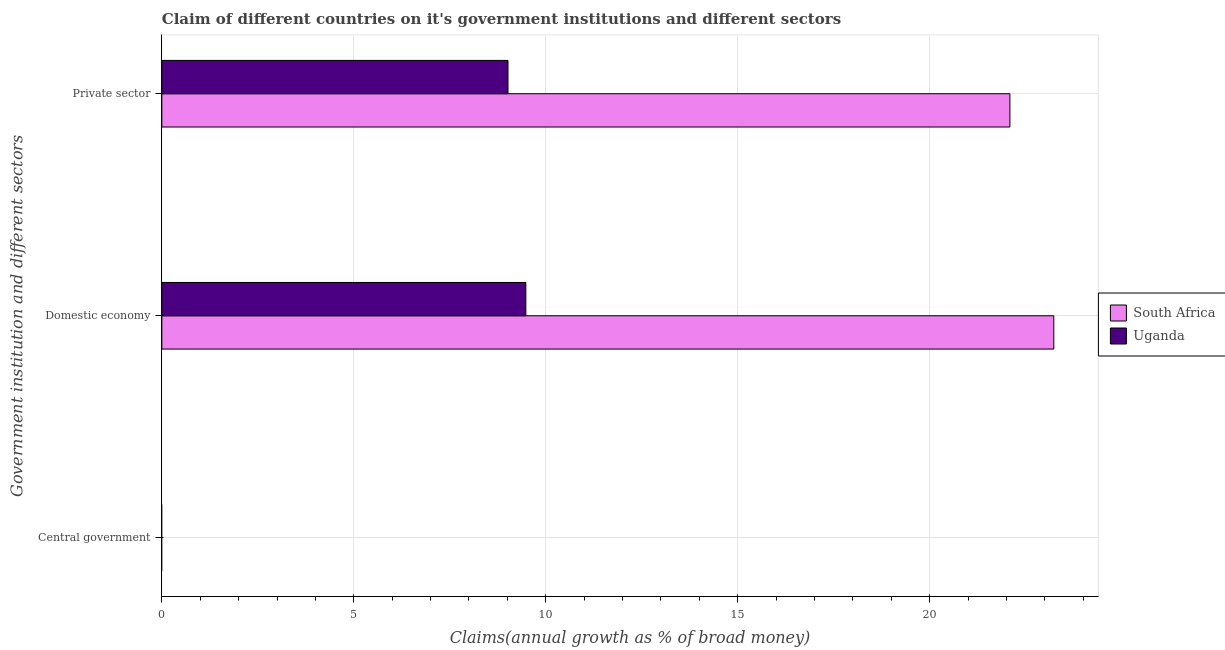How many different coloured bars are there?
Your answer should be very brief. 2. Are the number of bars per tick equal to the number of legend labels?
Give a very brief answer. No. Are the number of bars on each tick of the Y-axis equal?
Your answer should be compact. No. How many bars are there on the 1st tick from the top?
Keep it short and to the point. 2. How many bars are there on the 1st tick from the bottom?
Keep it short and to the point. 0. What is the label of the 2nd group of bars from the top?
Your response must be concise. Domestic economy. What is the percentage of claim on the domestic economy in South Africa?
Give a very brief answer. 23.23. Across all countries, what is the maximum percentage of claim on the private sector?
Provide a succinct answer. 22.09. Across all countries, what is the minimum percentage of claim on the central government?
Offer a very short reply. 0. In which country was the percentage of claim on the private sector maximum?
Your answer should be compact. South Africa. What is the total percentage of claim on the central government in the graph?
Provide a short and direct response. 0. What is the difference between the percentage of claim on the private sector in Uganda and that in South Africa?
Keep it short and to the point. -13.07. What is the difference between the percentage of claim on the central government in Uganda and the percentage of claim on the private sector in South Africa?
Give a very brief answer. -22.09. What is the average percentage of claim on the central government per country?
Ensure brevity in your answer.  0. What is the difference between the percentage of claim on the private sector and percentage of claim on the domestic economy in Uganda?
Your answer should be compact. -0.46. In how many countries, is the percentage of claim on the central government greater than 13 %?
Give a very brief answer. 0. What is the ratio of the percentage of claim on the private sector in Uganda to that in South Africa?
Provide a short and direct response. 0.41. Is the percentage of claim on the domestic economy in South Africa less than that in Uganda?
Your answer should be very brief. No. Is the difference between the percentage of claim on the domestic economy in South Africa and Uganda greater than the difference between the percentage of claim on the private sector in South Africa and Uganda?
Give a very brief answer. Yes. What is the difference between the highest and the second highest percentage of claim on the domestic economy?
Offer a terse response. 13.75. What is the difference between the highest and the lowest percentage of claim on the private sector?
Your response must be concise. 13.07. In how many countries, is the percentage of claim on the central government greater than the average percentage of claim on the central government taken over all countries?
Your answer should be very brief. 0. Is it the case that in every country, the sum of the percentage of claim on the central government and percentage of claim on the domestic economy is greater than the percentage of claim on the private sector?
Ensure brevity in your answer.  Yes. How many bars are there?
Offer a very short reply. 4. What is the difference between two consecutive major ticks on the X-axis?
Keep it short and to the point. 5. Where does the legend appear in the graph?
Provide a succinct answer. Center right. How many legend labels are there?
Provide a succinct answer. 2. What is the title of the graph?
Your response must be concise. Claim of different countries on it's government institutions and different sectors. Does "Japan" appear as one of the legend labels in the graph?
Your answer should be compact. No. What is the label or title of the X-axis?
Offer a terse response. Claims(annual growth as % of broad money). What is the label or title of the Y-axis?
Provide a short and direct response. Government institution and different sectors. What is the Claims(annual growth as % of broad money) in South Africa in Domestic economy?
Give a very brief answer. 23.23. What is the Claims(annual growth as % of broad money) in Uganda in Domestic economy?
Your response must be concise. 9.48. What is the Claims(annual growth as % of broad money) in South Africa in Private sector?
Keep it short and to the point. 22.09. What is the Claims(annual growth as % of broad money) in Uganda in Private sector?
Offer a terse response. 9.02. Across all Government institution and different sectors, what is the maximum Claims(annual growth as % of broad money) in South Africa?
Offer a terse response. 23.23. Across all Government institution and different sectors, what is the maximum Claims(annual growth as % of broad money) in Uganda?
Make the answer very short. 9.48. What is the total Claims(annual growth as % of broad money) in South Africa in the graph?
Your response must be concise. 45.32. What is the total Claims(annual growth as % of broad money) in Uganda in the graph?
Offer a very short reply. 18.5. What is the difference between the Claims(annual growth as % of broad money) in South Africa in Domestic economy and that in Private sector?
Keep it short and to the point. 1.14. What is the difference between the Claims(annual growth as % of broad money) of Uganda in Domestic economy and that in Private sector?
Offer a terse response. 0.46. What is the difference between the Claims(annual growth as % of broad money) in South Africa in Domestic economy and the Claims(annual growth as % of broad money) in Uganda in Private sector?
Your answer should be very brief. 14.22. What is the average Claims(annual growth as % of broad money) in South Africa per Government institution and different sectors?
Your answer should be compact. 15.11. What is the average Claims(annual growth as % of broad money) in Uganda per Government institution and different sectors?
Offer a terse response. 6.17. What is the difference between the Claims(annual growth as % of broad money) of South Africa and Claims(annual growth as % of broad money) of Uganda in Domestic economy?
Your response must be concise. 13.75. What is the difference between the Claims(annual growth as % of broad money) in South Africa and Claims(annual growth as % of broad money) in Uganda in Private sector?
Offer a terse response. 13.07. What is the ratio of the Claims(annual growth as % of broad money) in South Africa in Domestic economy to that in Private sector?
Your response must be concise. 1.05. What is the ratio of the Claims(annual growth as % of broad money) in Uganda in Domestic economy to that in Private sector?
Offer a terse response. 1.05. What is the difference between the highest and the lowest Claims(annual growth as % of broad money) of South Africa?
Your response must be concise. 23.23. What is the difference between the highest and the lowest Claims(annual growth as % of broad money) of Uganda?
Your answer should be compact. 9.48. 